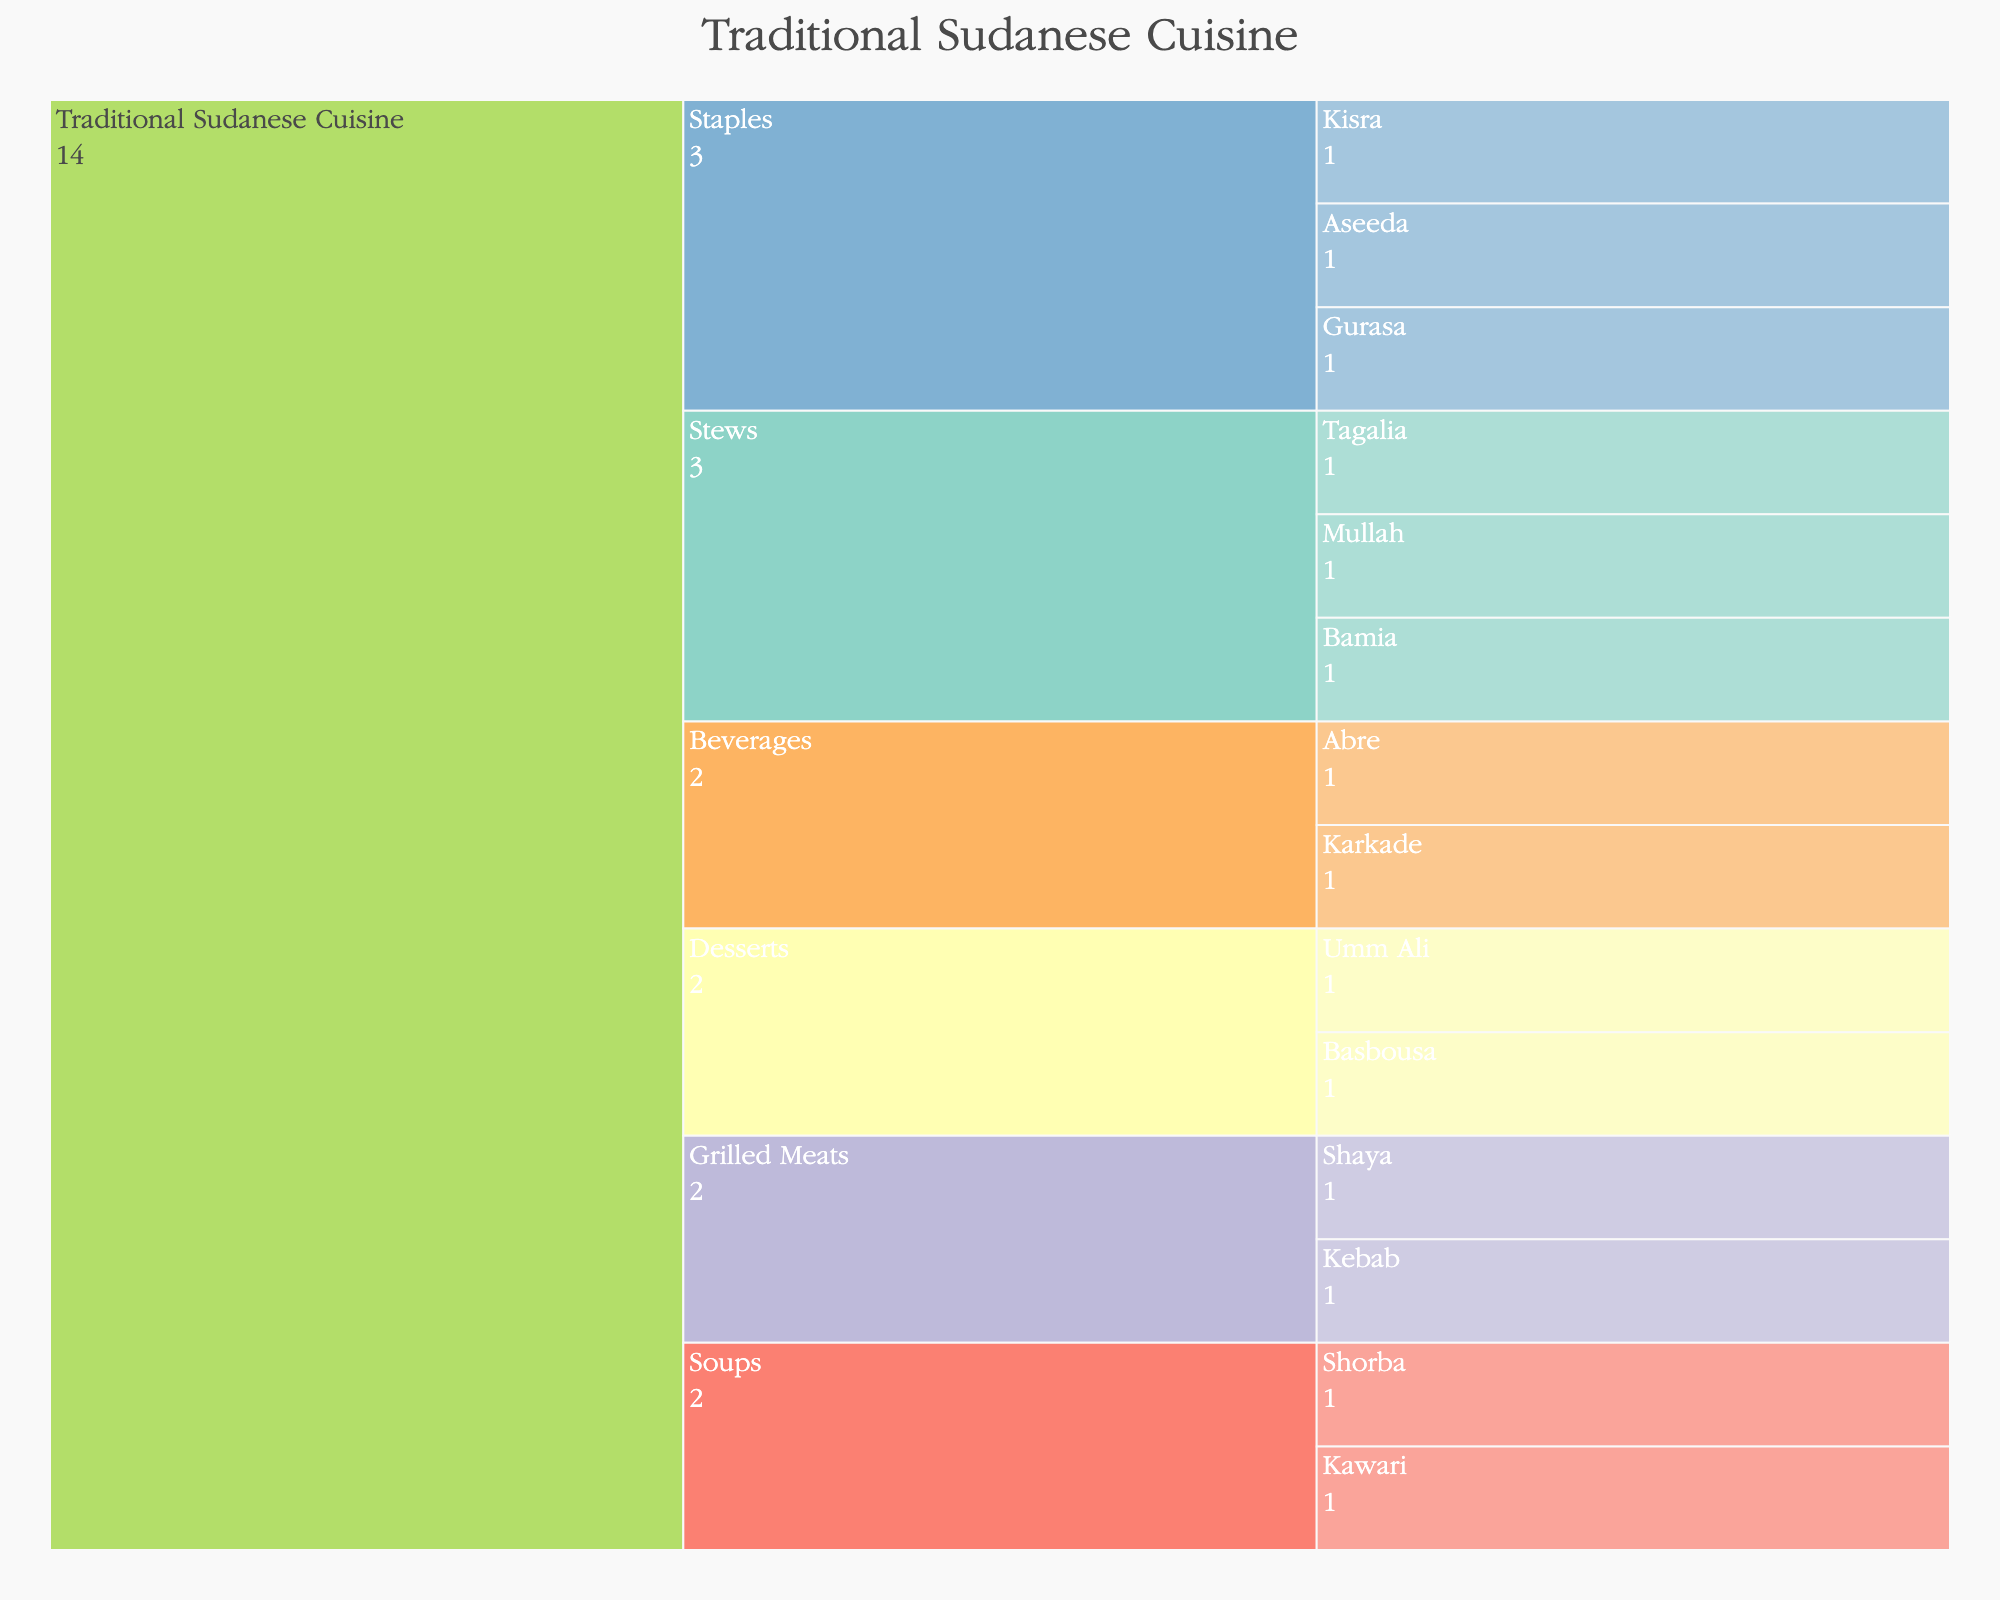Which cuisine category has the highest number of subcategories? The icicle chart is structured hierarchically and at the top level, we see "Traditional Sudanese Cuisine". By counting the subcategories branching off from it (Staples, Stews, Grilled Meats, Soups, Desserts, Beverages), we can see that there are 6 subcategories.
Answer: Traditional Sudanese Cuisine How many dishes are listed under the "Desserts" subcategory? The icicle chart shows that the "Desserts" subcategory has two dishes branching from it.
Answer: 2 What are the staple dishes presented in the figure? The "Staples" subcategory branches into three dishes at the next level. By looking at these branches, we can identify the dishes as Kisra, Aseeda, and Gurasa.
Answer: Kisra, Aseeda, Gurasa Which subcategory has only one dish listed? Looking at the icicle chart, all subcategories except for "Grilled Meats" and "Beverages" have multiple branches. Both "Staples" and "Stews" have more than one dish listed. Therefore, "Grilled Meats" and "Beverages" are the subcategories with one dish each.
Answer: Grilled Meats, Beverages How many categories of traditional Sudanese cuisine are displayed in the chart? The top level of the icicle chart only shows one category, "Traditional Sudanese Cuisine", so there is only one category total.
Answer: 1 What are the different types of beverages mentioned in the chart? Focusing on the branch labeled "Beverages", we see two further branches: Karkade and Abre. These are the beverages listed under traditional Sudanese cuisine.
Answer: Karkade, Abre Which subcategory of traditional Sudanese cuisine has the most dishes listed? By examining each subcategory and counting the dishes branching off each, we see that "Stews" has three dishes listed: Mullah, Tagalia, and Bamia. Other subcategories either have one or two dishes each. Therefore, "Stews" has the most dishes.
Answer: Stews What proportion of the dishes in the chart are soups? To find this, count the total number of dishes and those under the "Soups" subcategory. There are a total of 14 dishes (3 Staples, 3 Stews, 2 Grilled Meats, 2 Soups, 2 Desserts, 2 Beverages). Soups are Kawari and Shorba, thus 2 out of 14.
Answer: 2/14 Which dish falls under the "Grilled Meats" category? There are two dishes listed under the "Grilled Meats" subcategory: Shaya and Kebab.
Answer: Shaya, Kebab 